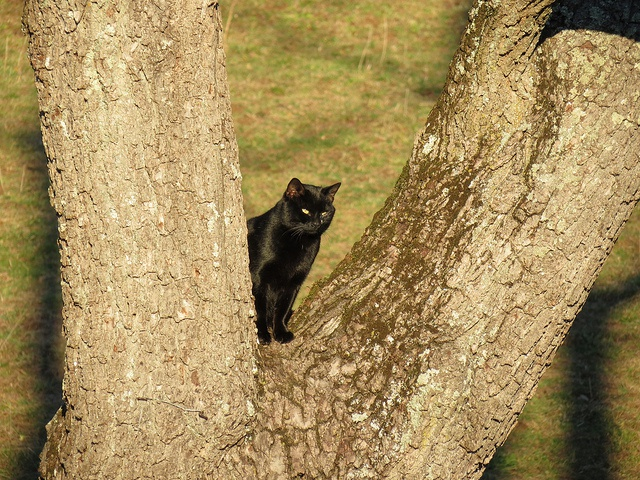Describe the objects in this image and their specific colors. I can see a cat in olive, black, gray, and tan tones in this image. 